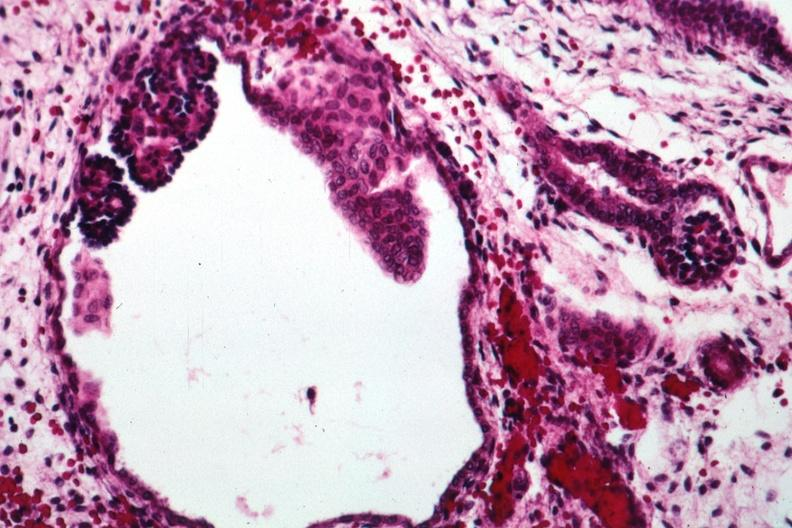does this image show abortive glomeruli?
Answer the question using a single word or phrase. Yes 